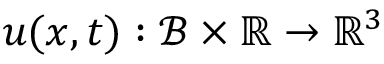<formula> <loc_0><loc_0><loc_500><loc_500>u ( x , t ) \colon \mathcal { B } \times \mathbb { R } \rightarrow \mathbb { R } ^ { 3 }</formula> 